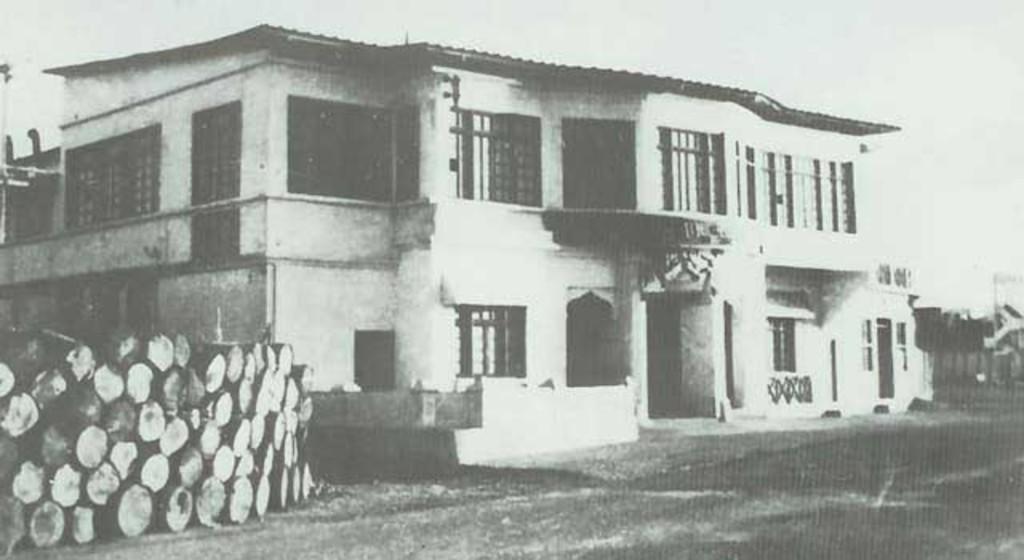Please provide a concise description of this image. It is a black and white image. This is the house, on the left side there are logs. At the top it is a sky. 